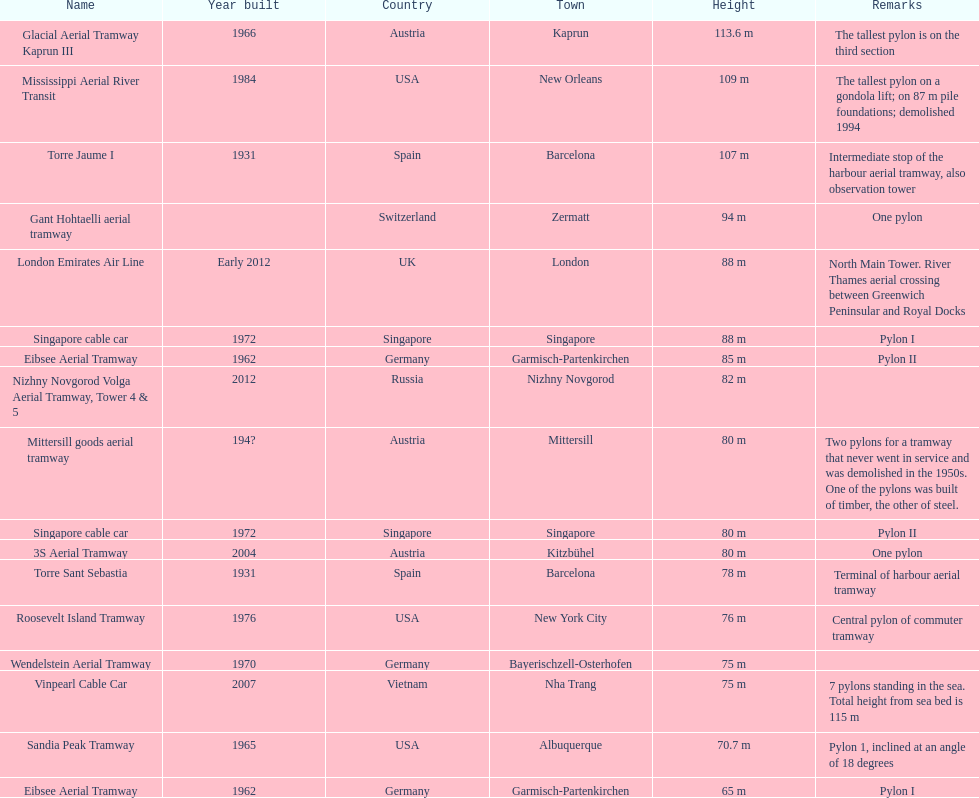How many metres is the mississippi aerial river transit from bottom to top? 109 m. 